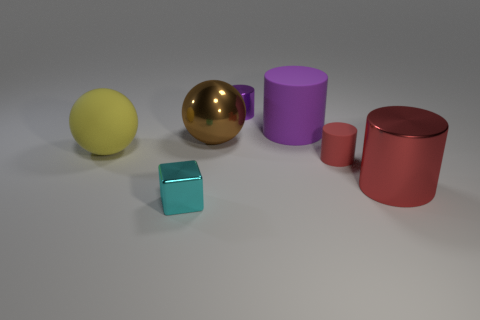Subtract all tiny purple metal cylinders. How many cylinders are left? 3 Add 1 purple matte objects. How many objects exist? 8 Subtract all green cylinders. Subtract all blue balls. How many cylinders are left? 4 Subtract all blocks. How many objects are left? 6 Subtract all gray rubber cylinders. Subtract all small red objects. How many objects are left? 6 Add 4 big matte things. How many big matte things are left? 6 Add 6 tiny yellow spheres. How many tiny yellow spheres exist? 6 Subtract 0 yellow cylinders. How many objects are left? 7 